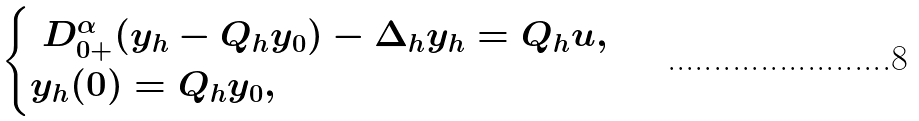Convert formula to latex. <formula><loc_0><loc_0><loc_500><loc_500>\begin{cases} \ D _ { 0 + } ^ { \alpha } ( y _ { h } - Q _ { h } y _ { 0 } ) - \Delta _ { h } y _ { h } = Q _ { h } u , \\ y _ { h } ( 0 ) = Q _ { h } y _ { 0 } , \end{cases}</formula> 